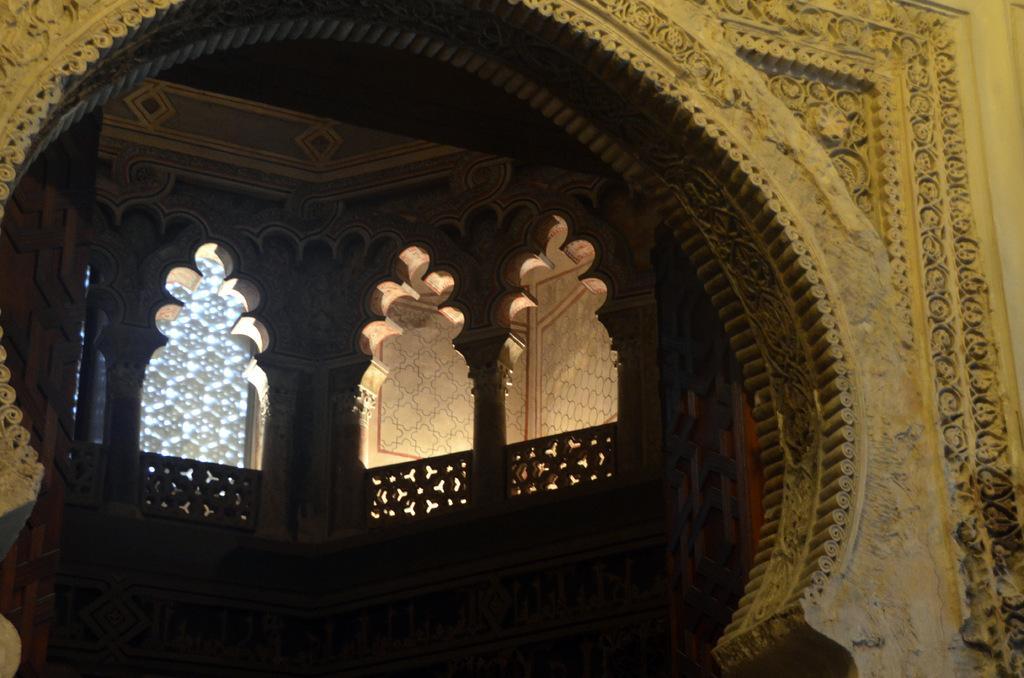Describe this image in one or two sentences. In front of the picture, it looks like an arch. On the right side, we see a wall. In this picture, we see a building. We see the pillars and the railing. In the background, we see a wall. 